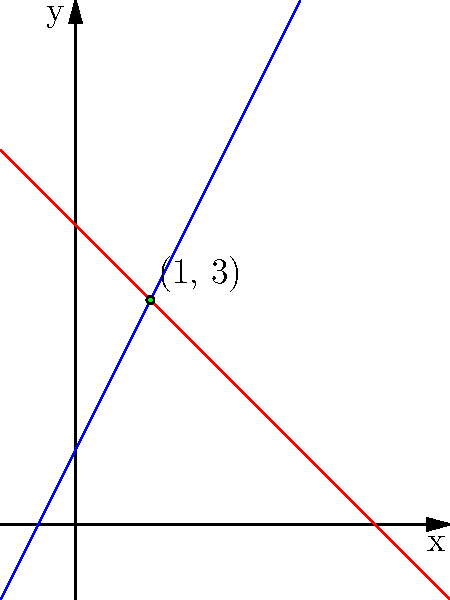During your free time in the prison library, you come across a math textbook and decide to challenge yourself. You encounter a problem about finding the intersection point of two lines. The equations of the lines are $y = 2x + 1$ and $y = -x + 4$. Determine the coordinates of the point where these lines intersect. To find the intersection point, we need to solve the system of equations:

1) $y = 2x + 1$
2) $y = -x + 4$

Step 1: Since both equations equal $y$, we can set them equal to each other:
$2x + 1 = -x + 4$

Step 2: Add $x$ to both sides:
$3x + 1 = 4$

Step 3: Subtract 1 from both sides:
$3x = 3$

Step 4: Divide both sides by 3:
$x = 1$

Step 5: Now that we know $x = 1$, we can substitute this into either of the original equations. Let's use the first one:
$y = 2(1) + 1 = 2 + 1 = 3$

Therefore, the intersection point is $(1, 3)$.
Answer: $(1, 3)$ 